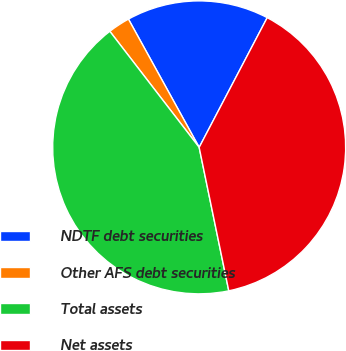Convert chart to OTSL. <chart><loc_0><loc_0><loc_500><loc_500><pie_chart><fcel>NDTF debt securities<fcel>Other AFS debt securities<fcel>Total assets<fcel>Net assets<nl><fcel>15.71%<fcel>2.42%<fcel>42.8%<fcel>39.07%<nl></chart> 